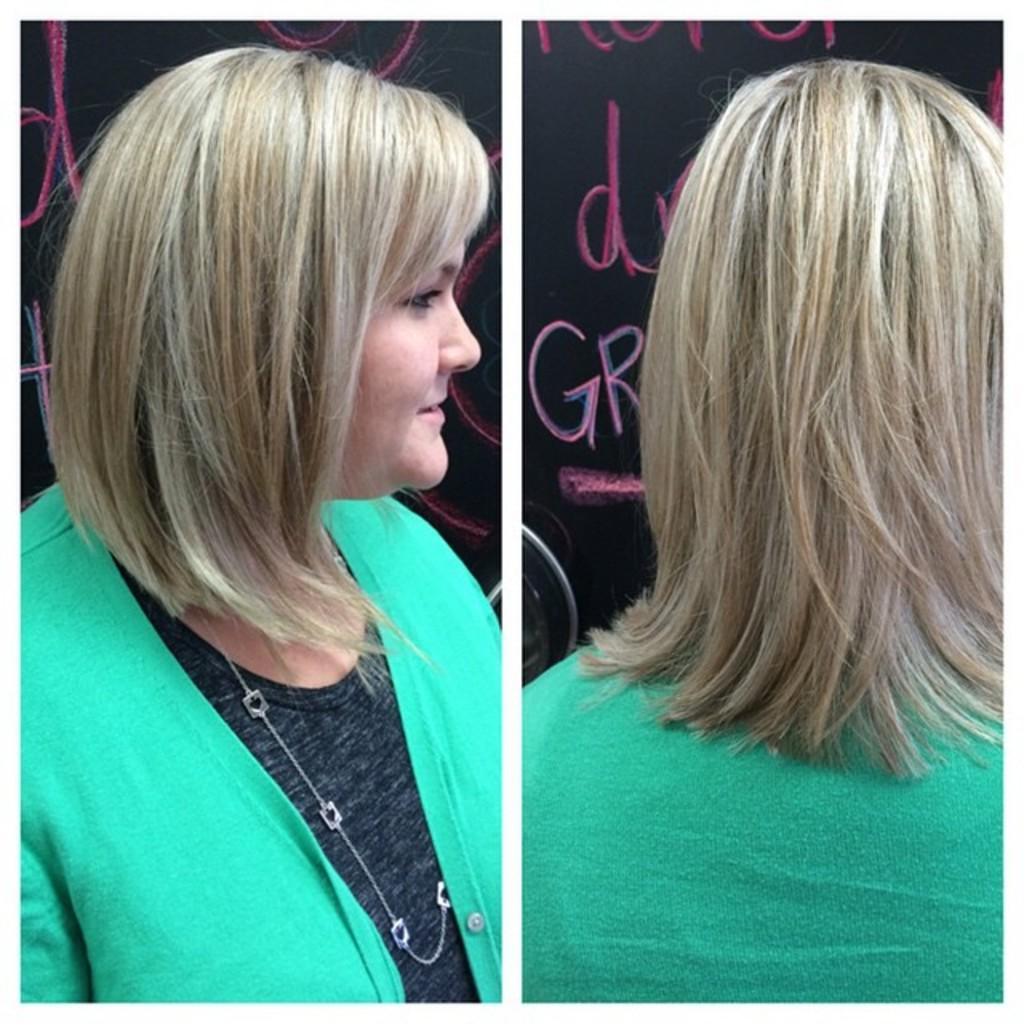How many women are present in the image? There are two women in the image, one on the right side and one on the left side. What can be seen in the background of the image? There is a wall in the background of the image. Is there any text visible in the image? Yes, there is text on the wall in the image. What is the woman on the right side of the image doing to smash the arm in the image? There is no arm present in the image, and the women are not depicted as smashing anything. 